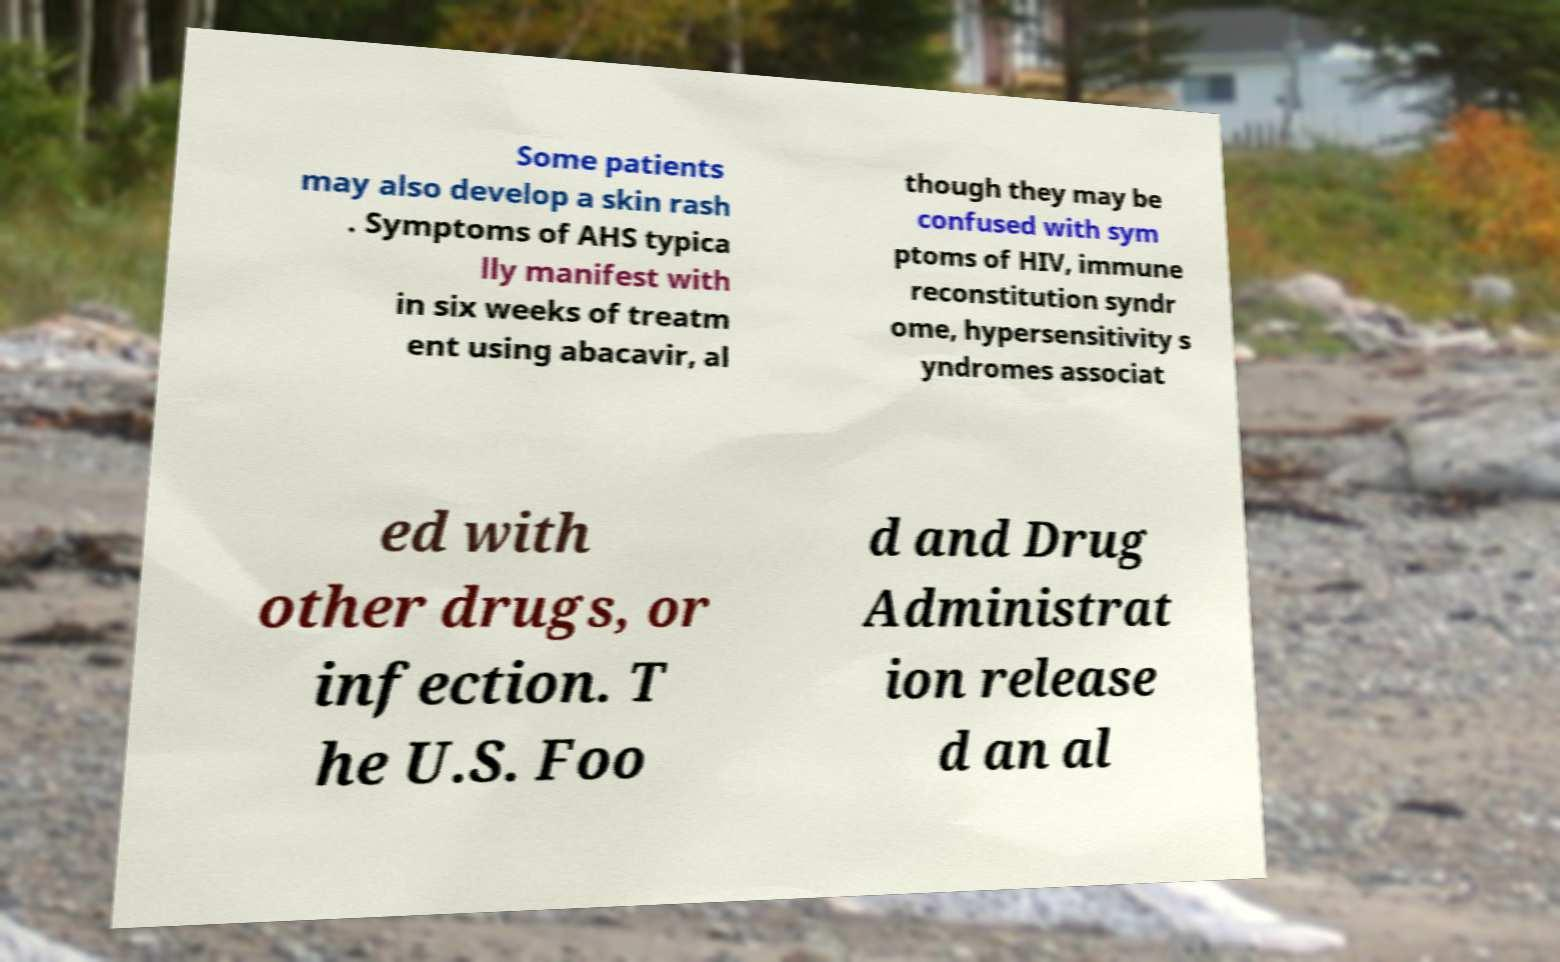For documentation purposes, I need the text within this image transcribed. Could you provide that? Some patients may also develop a skin rash . Symptoms of AHS typica lly manifest with in six weeks of treatm ent using abacavir, al though they may be confused with sym ptoms of HIV, immune reconstitution syndr ome, hypersensitivity s yndromes associat ed with other drugs, or infection. T he U.S. Foo d and Drug Administrat ion release d an al 